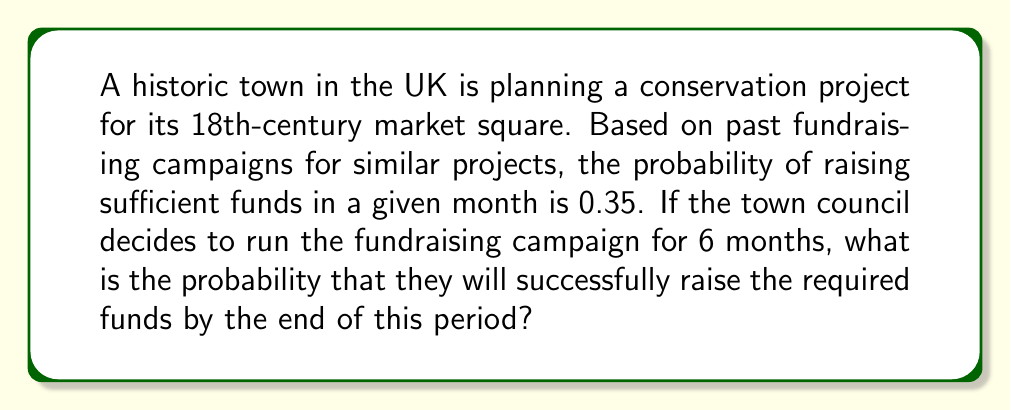Help me with this question. To solve this problem, we need to consider the probability of success over multiple independent trials. In this case, each month represents a trial, and we want to know the probability of at least one success in 6 trials.

Let's approach this step-by-step:

1. First, let's define our events:
   - Success (S): Raising sufficient funds in a given month
   - Failure (F): Not raising sufficient funds in a given month

2. We're given:
   - P(S) = 0.35 for each month
   - P(F) = 1 - P(S) = 1 - 0.35 = 0.65

3. We want to find the probability of at least one success in 6 months. It's often easier to calculate this by finding the probability of the complement event (no successes in 6 months) and subtracting it from 1.

4. The probability of no successes in 6 months is the probability of 6 consecutive failures:

   $P(\text{no success in 6 months}) = P(F)^6 = 0.65^6$

5. Therefore, the probability of at least one success in 6 months is:

   $P(\text{at least one success}) = 1 - P(\text{no success in 6 months})$

   $= 1 - 0.65^6$

6. Let's calculate this:
   
   $1 - 0.65^6 = 1 - 0.0754581$
   $= 0.9245419$

7. Converting to a percentage:
   
   $0.9245419 \times 100\% = 92.45\%$

Thus, the probability of successfully raising the required funds within the 6-month period is approximately 92.45%.
Answer: The probability of successfully raising the required funds for the conservation project within the 6-month period is approximately 92.45%. 